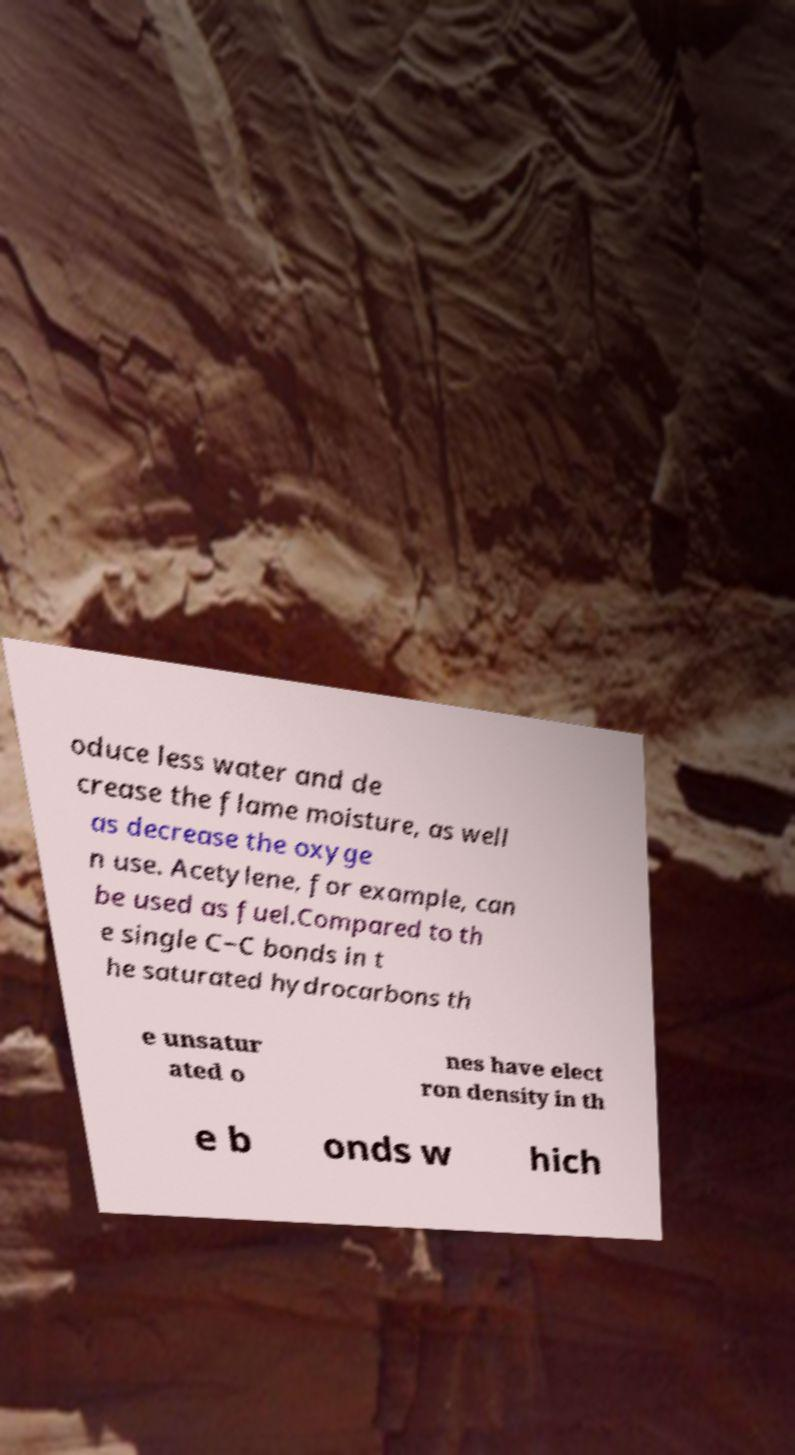Can you read and provide the text displayed in the image?This photo seems to have some interesting text. Can you extract and type it out for me? oduce less water and de crease the flame moisture, as well as decrease the oxyge n use. Acetylene, for example, can be used as fuel.Compared to th e single C−C bonds in t he saturated hydrocarbons th e unsatur ated o nes have elect ron density in th e b onds w hich 